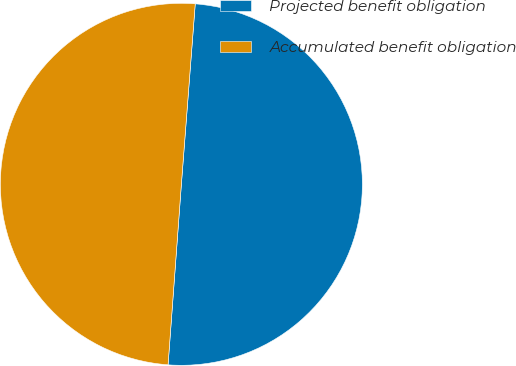Convert chart to OTSL. <chart><loc_0><loc_0><loc_500><loc_500><pie_chart><fcel>Projected benefit obligation<fcel>Accumulated benefit obligation<nl><fcel>49.95%<fcel>50.05%<nl></chart> 